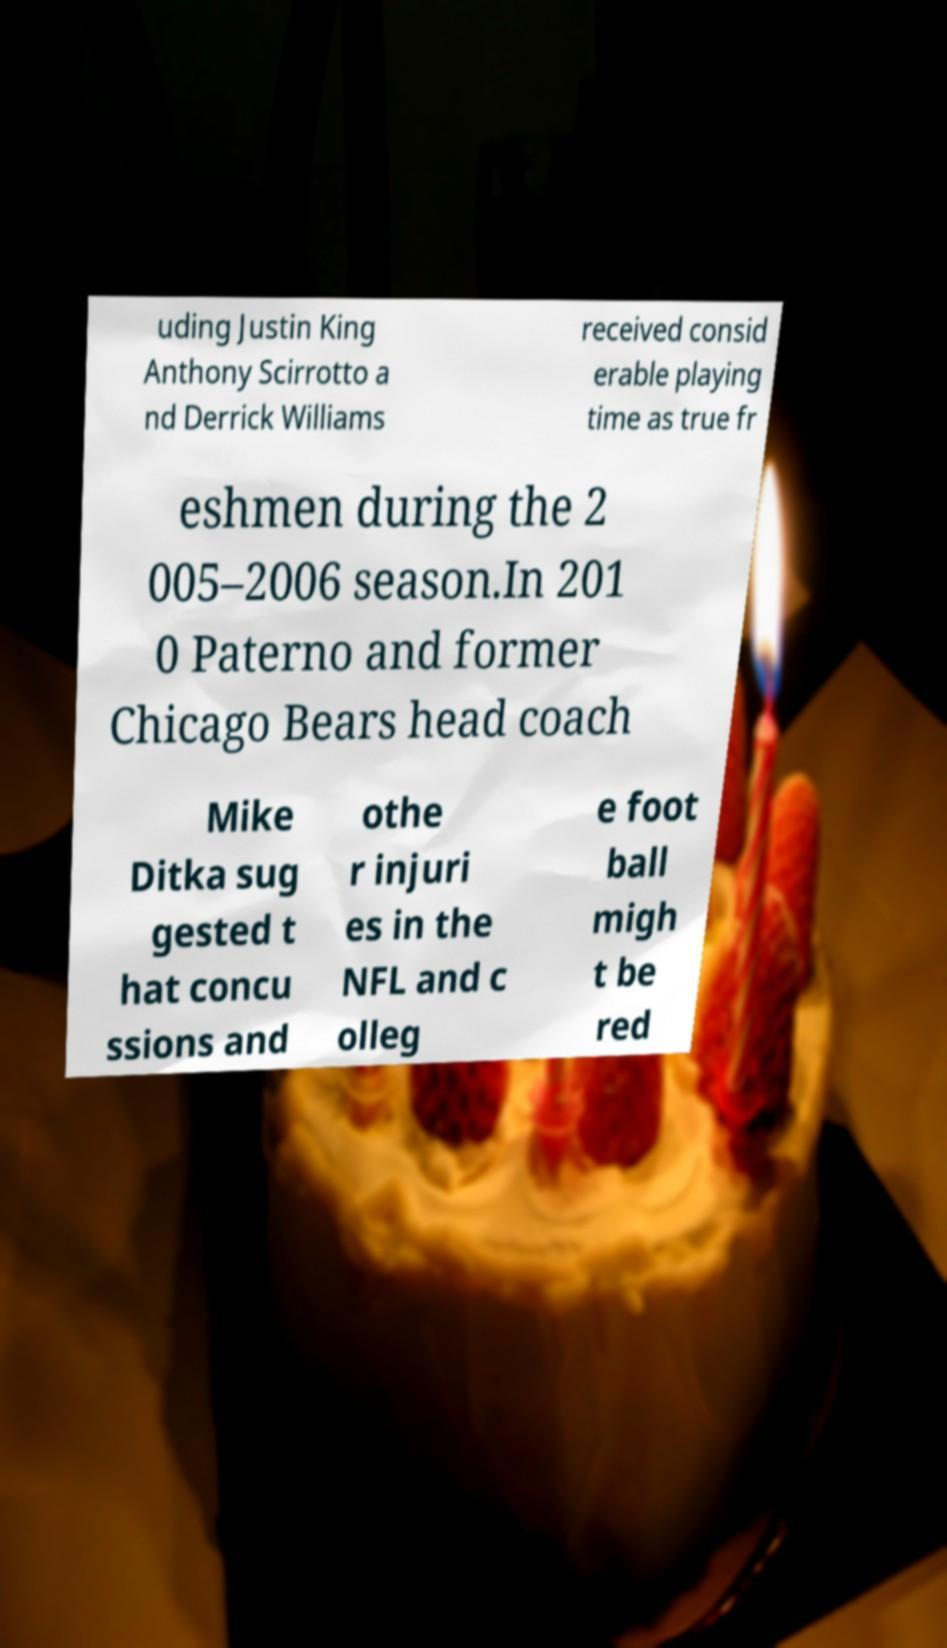Could you assist in decoding the text presented in this image and type it out clearly? uding Justin King Anthony Scirrotto a nd Derrick Williams received consid erable playing time as true fr eshmen during the 2 005–2006 season.In 201 0 Paterno and former Chicago Bears head coach Mike Ditka sug gested t hat concu ssions and othe r injuri es in the NFL and c olleg e foot ball migh t be red 